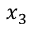Convert formula to latex. <formula><loc_0><loc_0><loc_500><loc_500>x _ { 3 }</formula> 